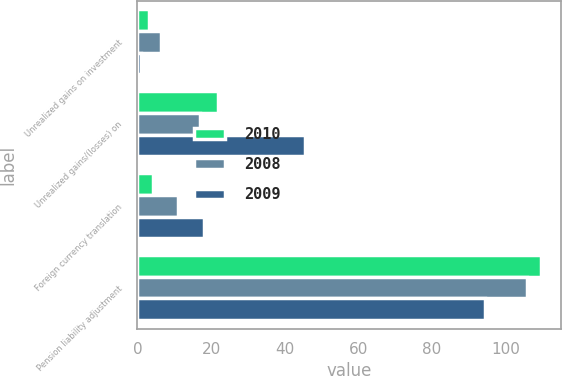<chart> <loc_0><loc_0><loc_500><loc_500><stacked_bar_chart><ecel><fcel>Unrealized gains on investment<fcel>Unrealized gains/(losses) on<fcel>Foreign currency translation<fcel>Pension liability adjustment<nl><fcel>2010<fcel>3.1<fcel>21.9<fcel>4.3<fcel>109.7<nl><fcel>2008<fcel>6.4<fcel>17<fcel>10.9<fcel>105.8<nl><fcel>2009<fcel>0.9<fcel>45.5<fcel>18.1<fcel>94.5<nl></chart> 